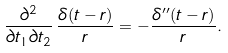Convert formula to latex. <formula><loc_0><loc_0><loc_500><loc_500>\frac { \partial ^ { 2 } } { \partial t _ { 1 } \partial t _ { 2 } } \, \frac { \delta ( t - r ) } { r } = - \frac { \delta ^ { \prime \prime } ( t - r ) } { r } .</formula> 